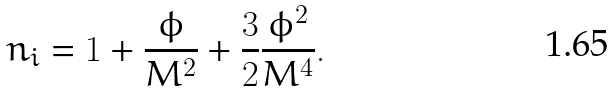<formula> <loc_0><loc_0><loc_500><loc_500>n _ { i } = 1 + \frac { \phi } { M ^ { 2 } } + \frac { 3 } { 2 } \frac { \phi ^ { 2 } } { M ^ { 4 } } .</formula> 